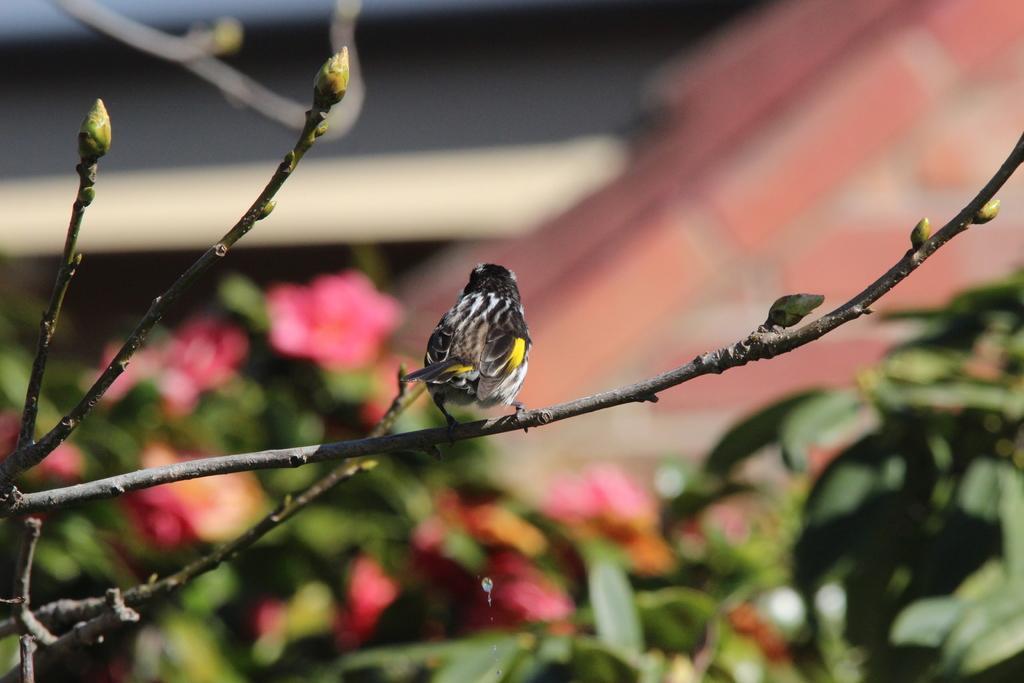Could you give a brief overview of what you see in this image? In this image we can see a bird on the branch and there are buds. There is a blur background. We can see plants and flowers. 